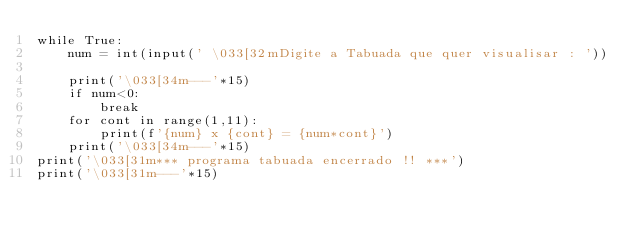Convert code to text. <code><loc_0><loc_0><loc_500><loc_500><_Python_>while True:
    num = int(input(' \033[32mDigite a Tabuada que quer visualisar : '))

    print('\033[34m---'*15)
    if num<0:
        break
    for cont in range(1,11):
        print(f'{num} x {cont} = {num*cont}')
    print('\033[34m---'*15)
print('\033[31m*** programa tabuada encerrado !! ***')
print('\033[31m---'*15)
</code> 